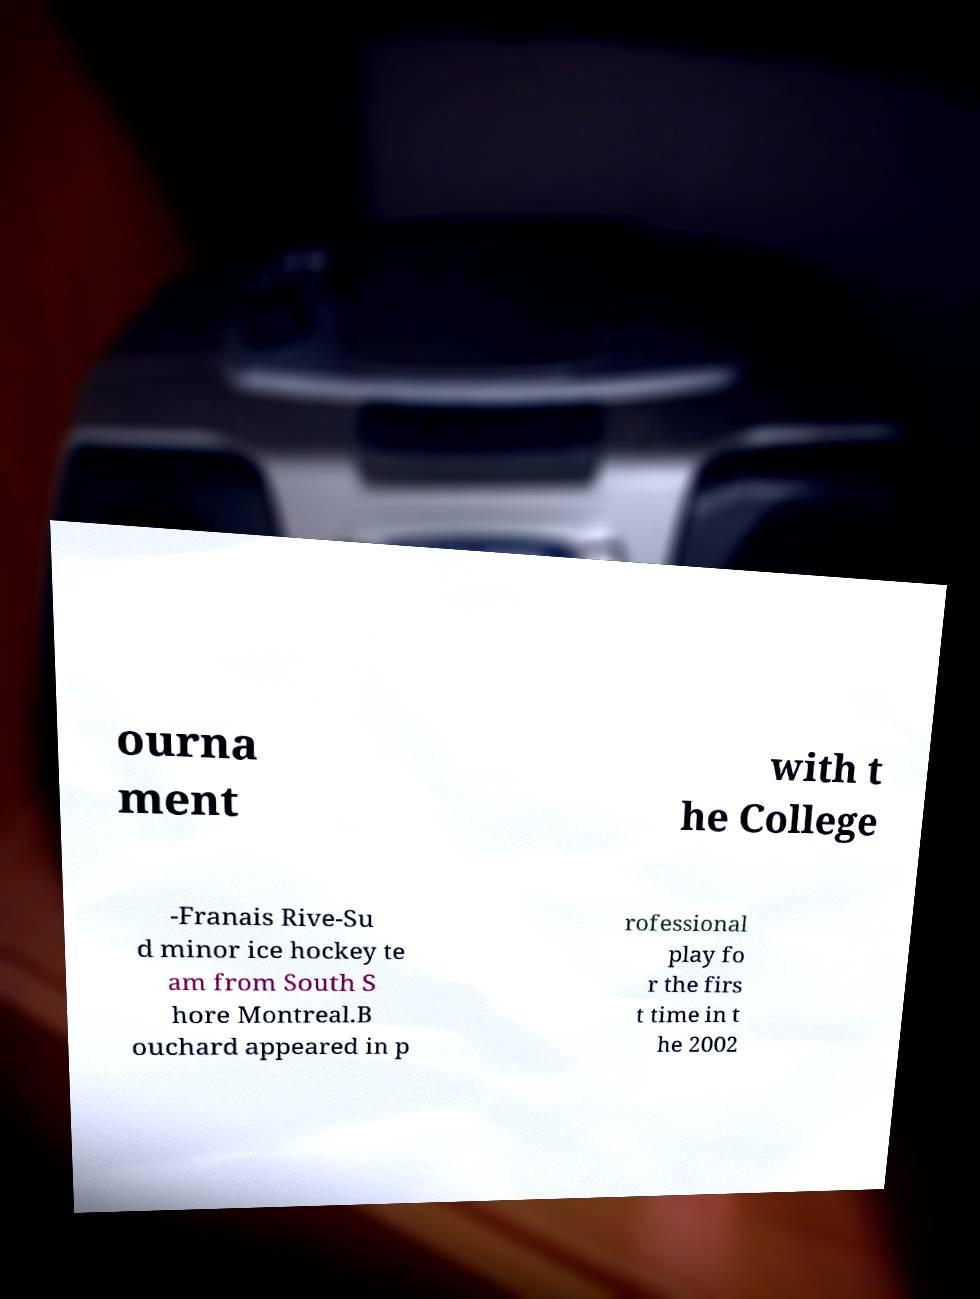Can you accurately transcribe the text from the provided image for me? ourna ment with t he College -Franais Rive-Su d minor ice hockey te am from South S hore Montreal.B ouchard appeared in p rofessional play fo r the firs t time in t he 2002 